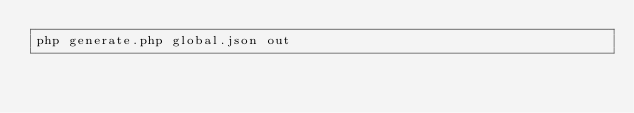<code> <loc_0><loc_0><loc_500><loc_500><_Bash_>php generate.php global.json out
</code> 